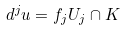<formula> <loc_0><loc_0><loc_500><loc_500>d ^ { j } u = f _ { j } U _ { j } \cap K</formula> 